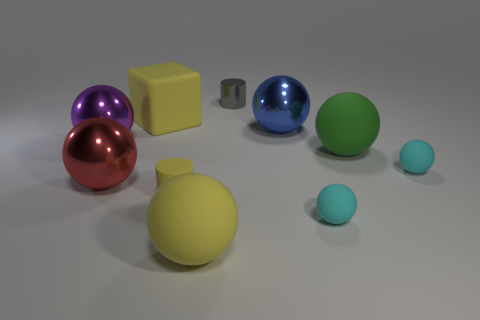The matte sphere that is the same color as the cube is what size?
Your response must be concise. Large. Is the color of the block the same as the tiny matte cylinder?
Your answer should be very brief. Yes. Do the small cylinder that is in front of the yellow cube and the rubber cube have the same color?
Make the answer very short. Yes. Are there any other things of the same color as the big matte block?
Give a very brief answer. Yes. What is the shape of the small matte thing that is the same color as the large rubber cube?
Keep it short and to the point. Cylinder. The large red metal object is what shape?
Provide a short and direct response. Sphere. Is the number of yellow matte cubes in front of the yellow ball less than the number of large green metallic blocks?
Your answer should be very brief. No. Is there a tiny cyan object of the same shape as the big purple object?
Your answer should be compact. Yes. What is the shape of the metallic thing that is the same size as the matte cylinder?
Your response must be concise. Cylinder. What number of things are yellow rubber things or big red shiny spheres?
Your response must be concise. 4. 